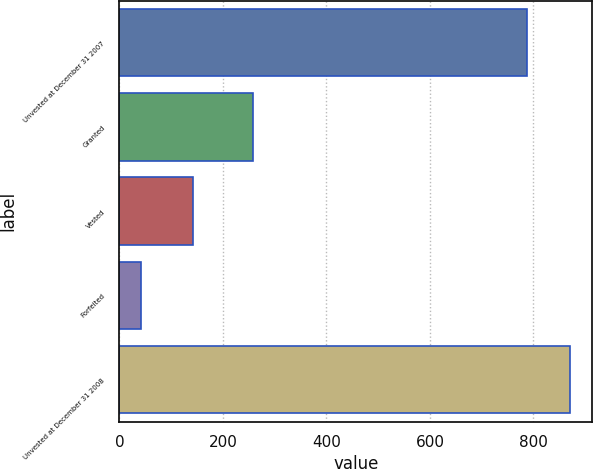Convert chart to OTSL. <chart><loc_0><loc_0><loc_500><loc_500><bar_chart><fcel>Unvested at December 31 2007<fcel>Granted<fcel>Vested<fcel>Forfeited<fcel>Unvested at December 31 2008<nl><fcel>788<fcel>259<fcel>142<fcel>41<fcel>870.3<nl></chart> 